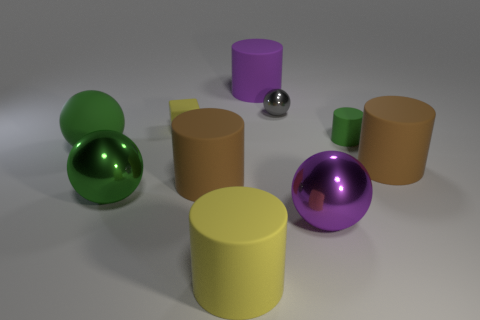What is the large purple object that is right of the purple matte cylinder made of? The large purple object to the right of the purple matte cylinder appears to be made of a glossy material, likely a type of plastic or polished metal, which gives it a reflective sheen. 